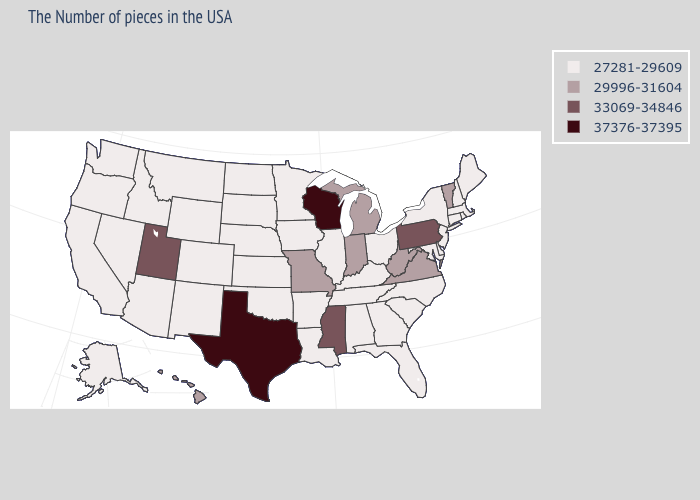What is the value of Ohio?
Be succinct. 27281-29609. Does the first symbol in the legend represent the smallest category?
Quick response, please. Yes. Which states have the lowest value in the USA?
Quick response, please. Maine, Massachusetts, Rhode Island, New Hampshire, Connecticut, New York, New Jersey, Delaware, Maryland, North Carolina, South Carolina, Ohio, Florida, Georgia, Kentucky, Alabama, Tennessee, Illinois, Louisiana, Arkansas, Minnesota, Iowa, Kansas, Nebraska, Oklahoma, South Dakota, North Dakota, Wyoming, Colorado, New Mexico, Montana, Arizona, Idaho, Nevada, California, Washington, Oregon, Alaska. What is the value of New Mexico?
Give a very brief answer. 27281-29609. What is the value of Massachusetts?
Short answer required. 27281-29609. What is the lowest value in the West?
Short answer required. 27281-29609. Does Hawaii have a lower value than Texas?
Short answer required. Yes. Does the first symbol in the legend represent the smallest category?
Give a very brief answer. Yes. Name the states that have a value in the range 29996-31604?
Give a very brief answer. Vermont, Virginia, West Virginia, Michigan, Indiana, Missouri, Hawaii. What is the value of Pennsylvania?
Write a very short answer. 33069-34846. Does Indiana have the lowest value in the MidWest?
Keep it brief. No. What is the value of South Carolina?
Answer briefly. 27281-29609. What is the value of West Virginia?
Quick response, please. 29996-31604. Name the states that have a value in the range 29996-31604?
Answer briefly. Vermont, Virginia, West Virginia, Michigan, Indiana, Missouri, Hawaii. What is the lowest value in states that border Oklahoma?
Keep it brief. 27281-29609. 